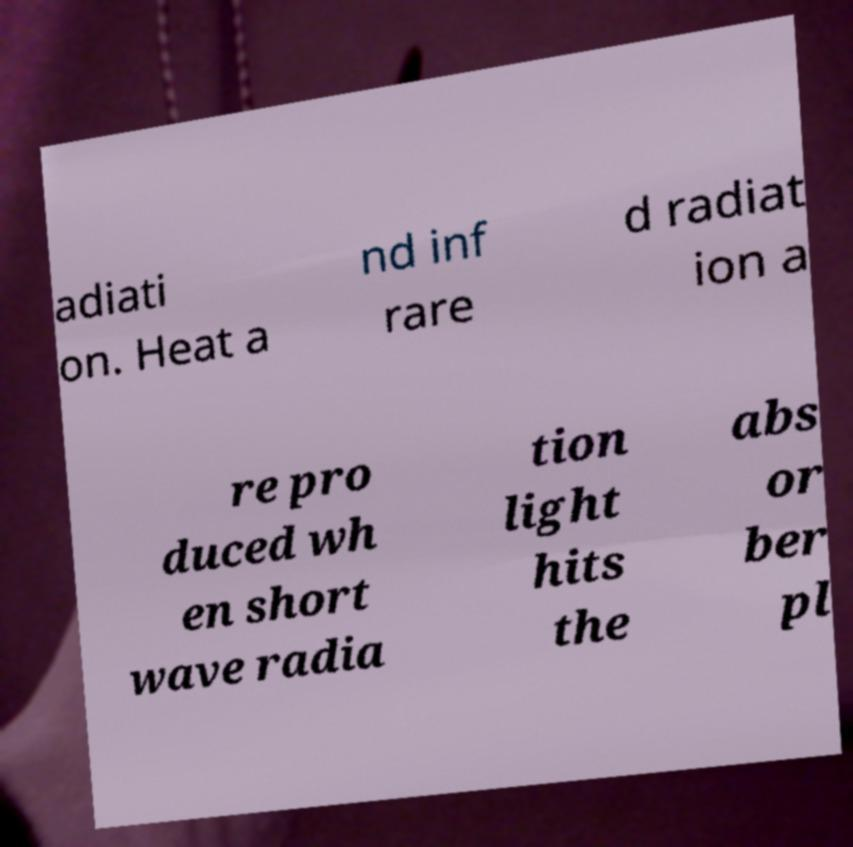Can you read and provide the text displayed in the image?This photo seems to have some interesting text. Can you extract and type it out for me? adiati on. Heat a nd inf rare d radiat ion a re pro duced wh en short wave radia tion light hits the abs or ber pl 